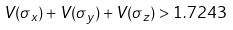Convert formula to latex. <formula><loc_0><loc_0><loc_500><loc_500>V ( \sigma _ { x } ) + V ( \sigma _ { y } ) + V ( \sigma _ { z } ) > 1 . 7 2 4 3</formula> 